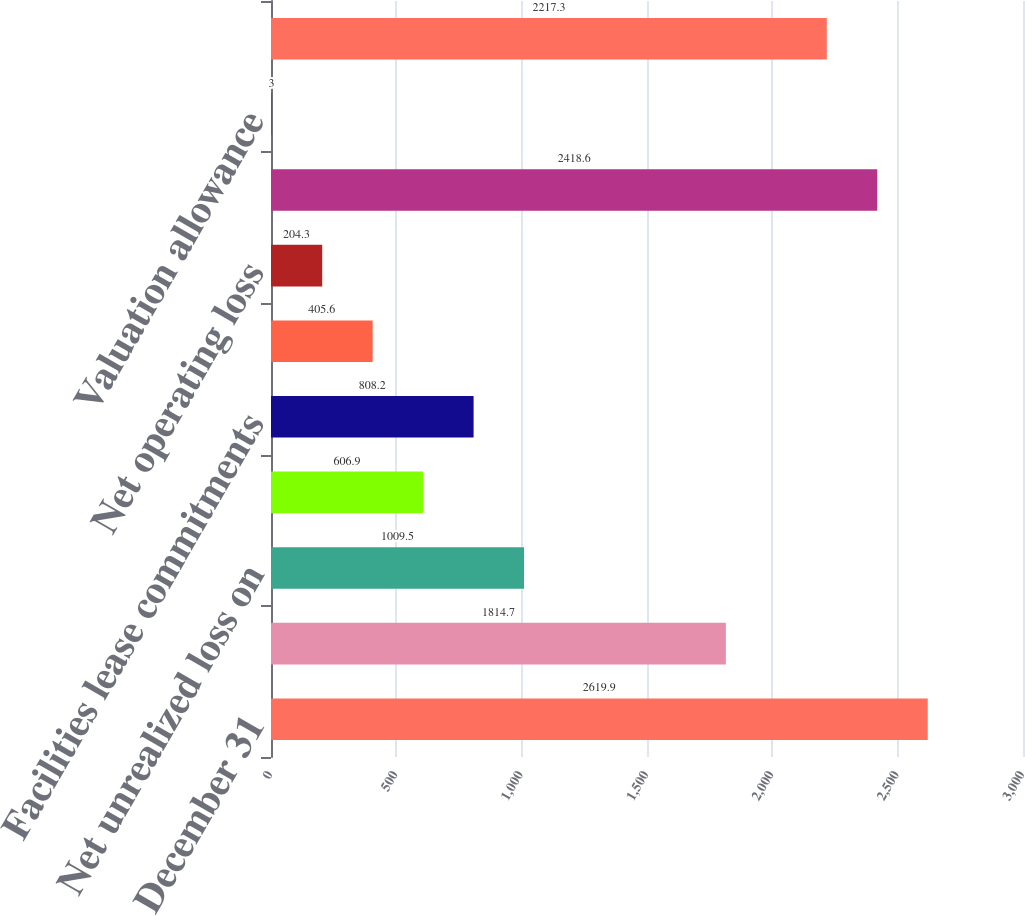<chart> <loc_0><loc_0><loc_500><loc_500><bar_chart><fcel>December 31<fcel>Employee compensation<fcel>Net unrealized loss on<fcel>Reserves and allowances<fcel>Facilities lease commitments<fcel>State and local taxes<fcel>Net operating loss<fcel>Total deferred tax assets<fcel>Valuation allowance<fcel>Deferred tax assets - net of<nl><fcel>2619.9<fcel>1814.7<fcel>1009.5<fcel>606.9<fcel>808.2<fcel>405.6<fcel>204.3<fcel>2418.6<fcel>3<fcel>2217.3<nl></chart> 